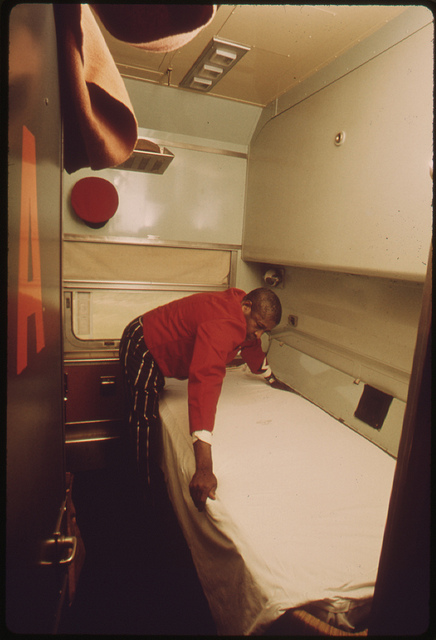Please extract the text content from this image. A 